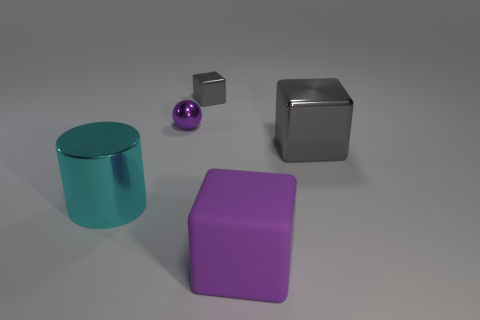Is there anything else that is the same material as the big purple object?
Your answer should be compact. No. Is the number of small metallic balls that are on the right side of the small shiny ball greater than the number of small red shiny blocks?
Your response must be concise. No. There is a gray metal block that is on the left side of the large shiny object that is behind the large shiny cylinder; what number of large purple matte blocks are in front of it?
Offer a very short reply. 1. There is a gray shiny object to the left of the large purple cube; is it the same size as the purple object that is to the left of the tiny gray thing?
Keep it short and to the point. Yes. There is a big object behind the large cyan thing that is on the left side of the small gray thing; what is its material?
Give a very brief answer. Metal. What number of objects are shiny things that are to the right of the purple cube or tiny purple metallic things?
Make the answer very short. 2. Is the number of shiny objects that are in front of the tiny purple metal sphere the same as the number of objects to the left of the purple block?
Offer a terse response. No. The tiny thing behind the purple thing behind the large cube behind the big matte thing is made of what material?
Offer a terse response. Metal. What is the size of the object that is behind the cyan shiny object and on the right side of the small gray metal block?
Your response must be concise. Large. Is the shape of the small gray thing the same as the purple rubber object?
Provide a succinct answer. Yes. 